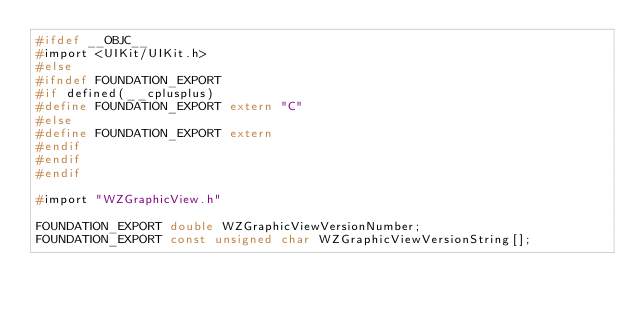<code> <loc_0><loc_0><loc_500><loc_500><_C_>#ifdef __OBJC__
#import <UIKit/UIKit.h>
#else
#ifndef FOUNDATION_EXPORT
#if defined(__cplusplus)
#define FOUNDATION_EXPORT extern "C"
#else
#define FOUNDATION_EXPORT extern
#endif
#endif
#endif

#import "WZGraphicView.h"

FOUNDATION_EXPORT double WZGraphicViewVersionNumber;
FOUNDATION_EXPORT const unsigned char WZGraphicViewVersionString[];

</code> 